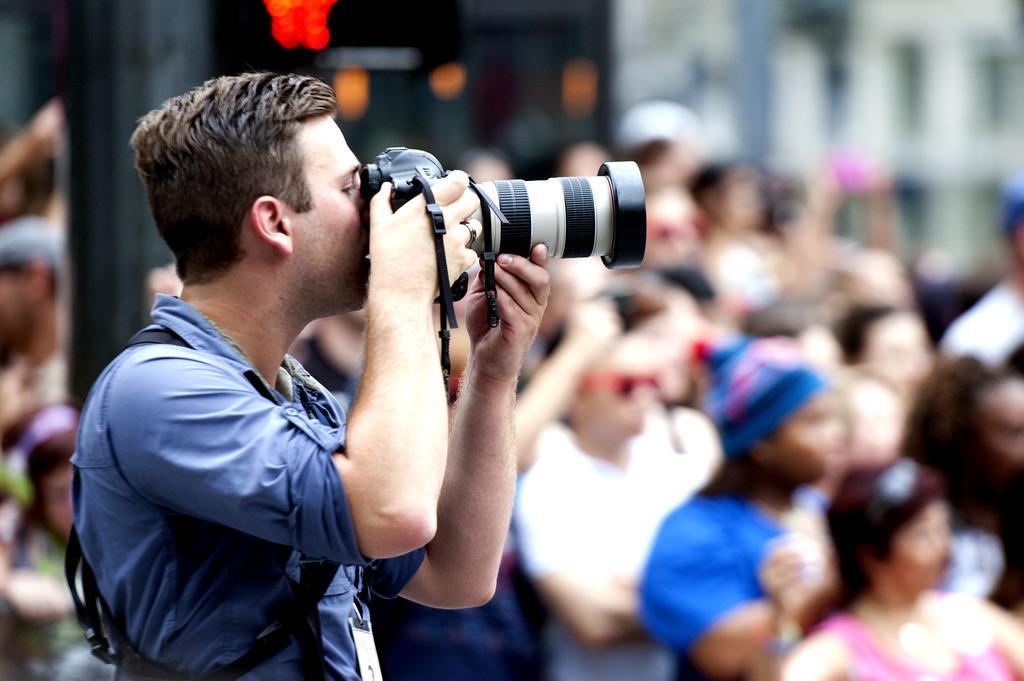Describe this image in one or two sentences. In the picture the person is wearing blue color shirt and holding camera and capturing he is also wearing id card, behind him there are lot of spectators who are sitting and watching. 